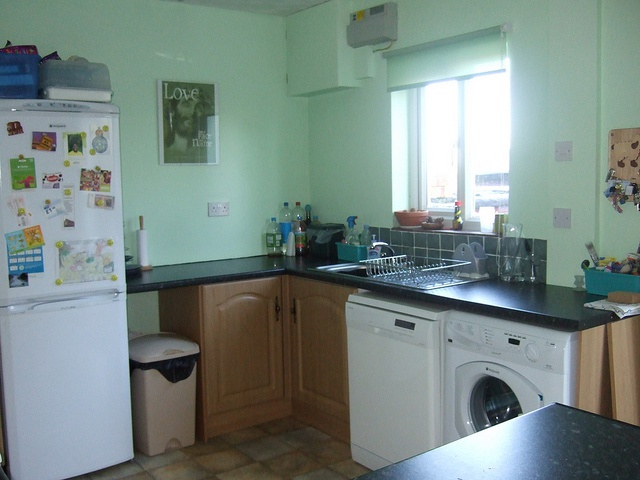Describe the objects in this image and their specific colors. I can see refrigerator in teal, darkgray, and gray tones, oven in teal, darkgray, gray, and black tones, dining table in teal, black, lightblue, and blue tones, bottle in teal, black, and darkgreen tones, and bowl in teal, gray, darkgray, and lightgray tones in this image. 